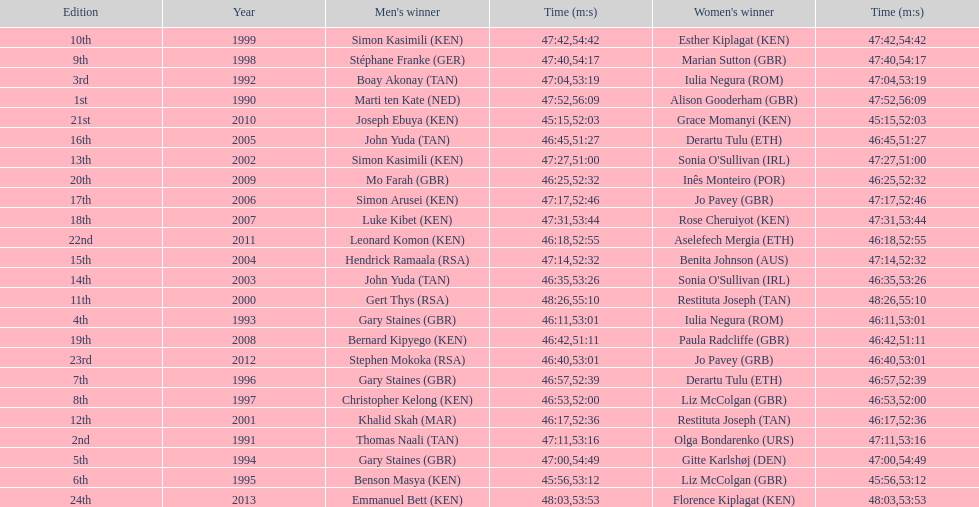What is the name of the first women's winner? Alison Gooderham. 